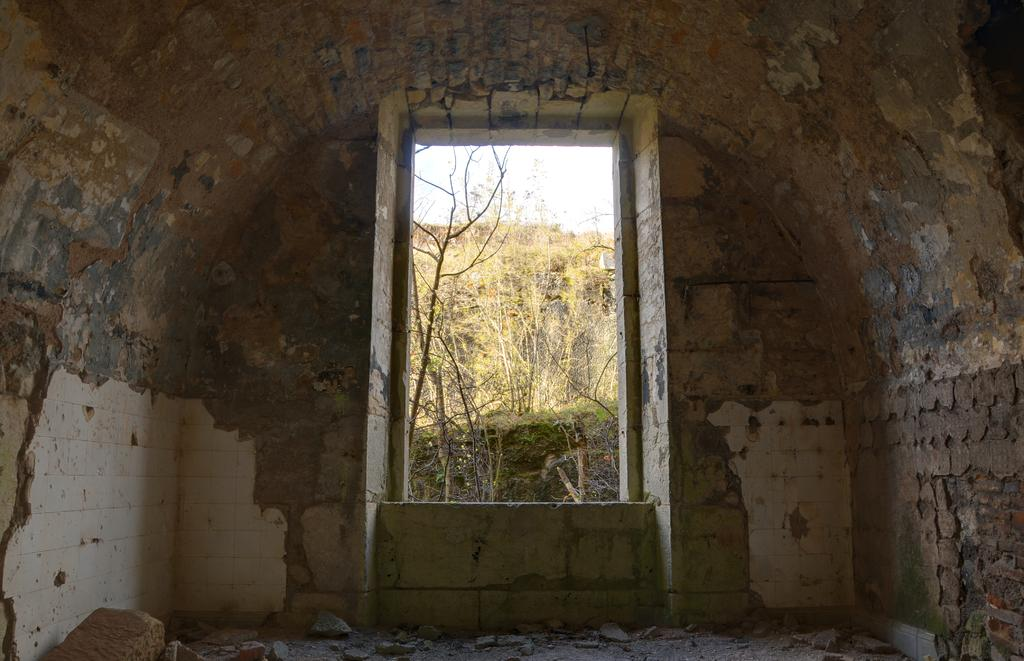What type of structure is present in the image? There is a building in the image. Can you describe any specific features of the building? There is a window in the image, which is a feature of the building. What can be seen in the background of the image? Trees are visible in the background of the image. What type of material is used for the wall in the image? There is a brick wall in the image. How would you describe the color of the sky in the image? The sky appears to be white in color. Can you tell me how many quince are hanging from the trees in the image? There are no quince visible in the image; only trees are present in the background. What type of mineral can be seen in the image? There is no mineral present in the image; it features a building, a window, trees, a brick wall, and a white sky. 